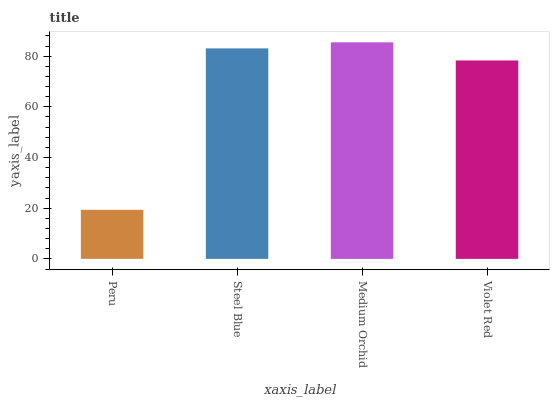Is Steel Blue the minimum?
Answer yes or no. No. Is Steel Blue the maximum?
Answer yes or no. No. Is Steel Blue greater than Peru?
Answer yes or no. Yes. Is Peru less than Steel Blue?
Answer yes or no. Yes. Is Peru greater than Steel Blue?
Answer yes or no. No. Is Steel Blue less than Peru?
Answer yes or no. No. Is Steel Blue the high median?
Answer yes or no. Yes. Is Violet Red the low median?
Answer yes or no. Yes. Is Violet Red the high median?
Answer yes or no. No. Is Steel Blue the low median?
Answer yes or no. No. 